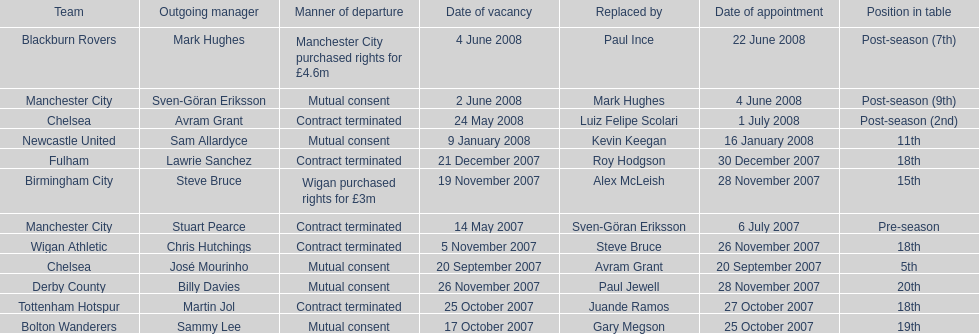Which new manager was purchased for the most money in the 2007-08 premier league season? Mark Hughes. Give me the full table as a dictionary. {'header': ['Team', 'Outgoing manager', 'Manner of departure', 'Date of vacancy', 'Replaced by', 'Date of appointment', 'Position in table'], 'rows': [['Blackburn Rovers', 'Mark Hughes', 'Manchester City purchased rights for £4.6m', '4 June 2008', 'Paul Ince', '22 June 2008', 'Post-season (7th)'], ['Manchester City', 'Sven-Göran Eriksson', 'Mutual consent', '2 June 2008', 'Mark Hughes', '4 June 2008', 'Post-season (9th)'], ['Chelsea', 'Avram Grant', 'Contract terminated', '24 May 2008', 'Luiz Felipe Scolari', '1 July 2008', 'Post-season (2nd)'], ['Newcastle United', 'Sam Allardyce', 'Mutual consent', '9 January 2008', 'Kevin Keegan', '16 January 2008', '11th'], ['Fulham', 'Lawrie Sanchez', 'Contract terminated', '21 December 2007', 'Roy Hodgson', '30 December 2007', '18th'], ['Birmingham City', 'Steve Bruce', 'Wigan purchased rights for £3m', '19 November 2007', 'Alex McLeish', '28 November 2007', '15th'], ['Manchester City', 'Stuart Pearce', 'Contract terminated', '14 May 2007', 'Sven-Göran Eriksson', '6 July 2007', 'Pre-season'], ['Wigan Athletic', 'Chris Hutchings', 'Contract terminated', '5 November 2007', 'Steve Bruce', '26 November 2007', '18th'], ['Chelsea', 'José Mourinho', 'Mutual consent', '20 September 2007', 'Avram Grant', '20 September 2007', '5th'], ['Derby County', 'Billy Davies', 'Mutual consent', '26 November 2007', 'Paul Jewell', '28 November 2007', '20th'], ['Tottenham Hotspur', 'Martin Jol', 'Contract terminated', '25 October 2007', 'Juande Ramos', '27 October 2007', '18th'], ['Bolton Wanderers', 'Sammy Lee', 'Mutual consent', '17 October 2007', 'Gary Megson', '25 October 2007', '19th']]} 